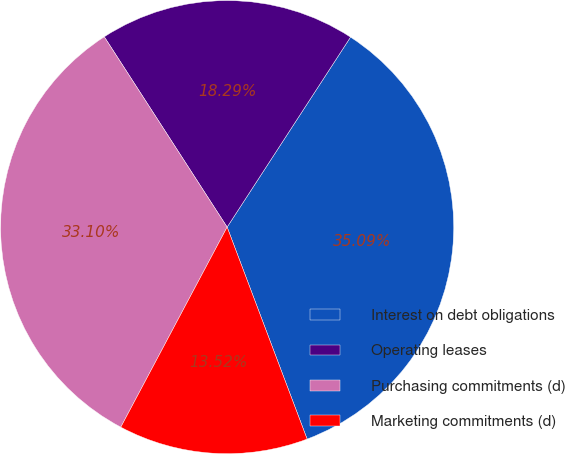Convert chart to OTSL. <chart><loc_0><loc_0><loc_500><loc_500><pie_chart><fcel>Interest on debt obligations<fcel>Operating leases<fcel>Purchasing commitments (d)<fcel>Marketing commitments (d)<nl><fcel>35.09%<fcel>18.29%<fcel>33.1%<fcel>13.52%<nl></chart> 